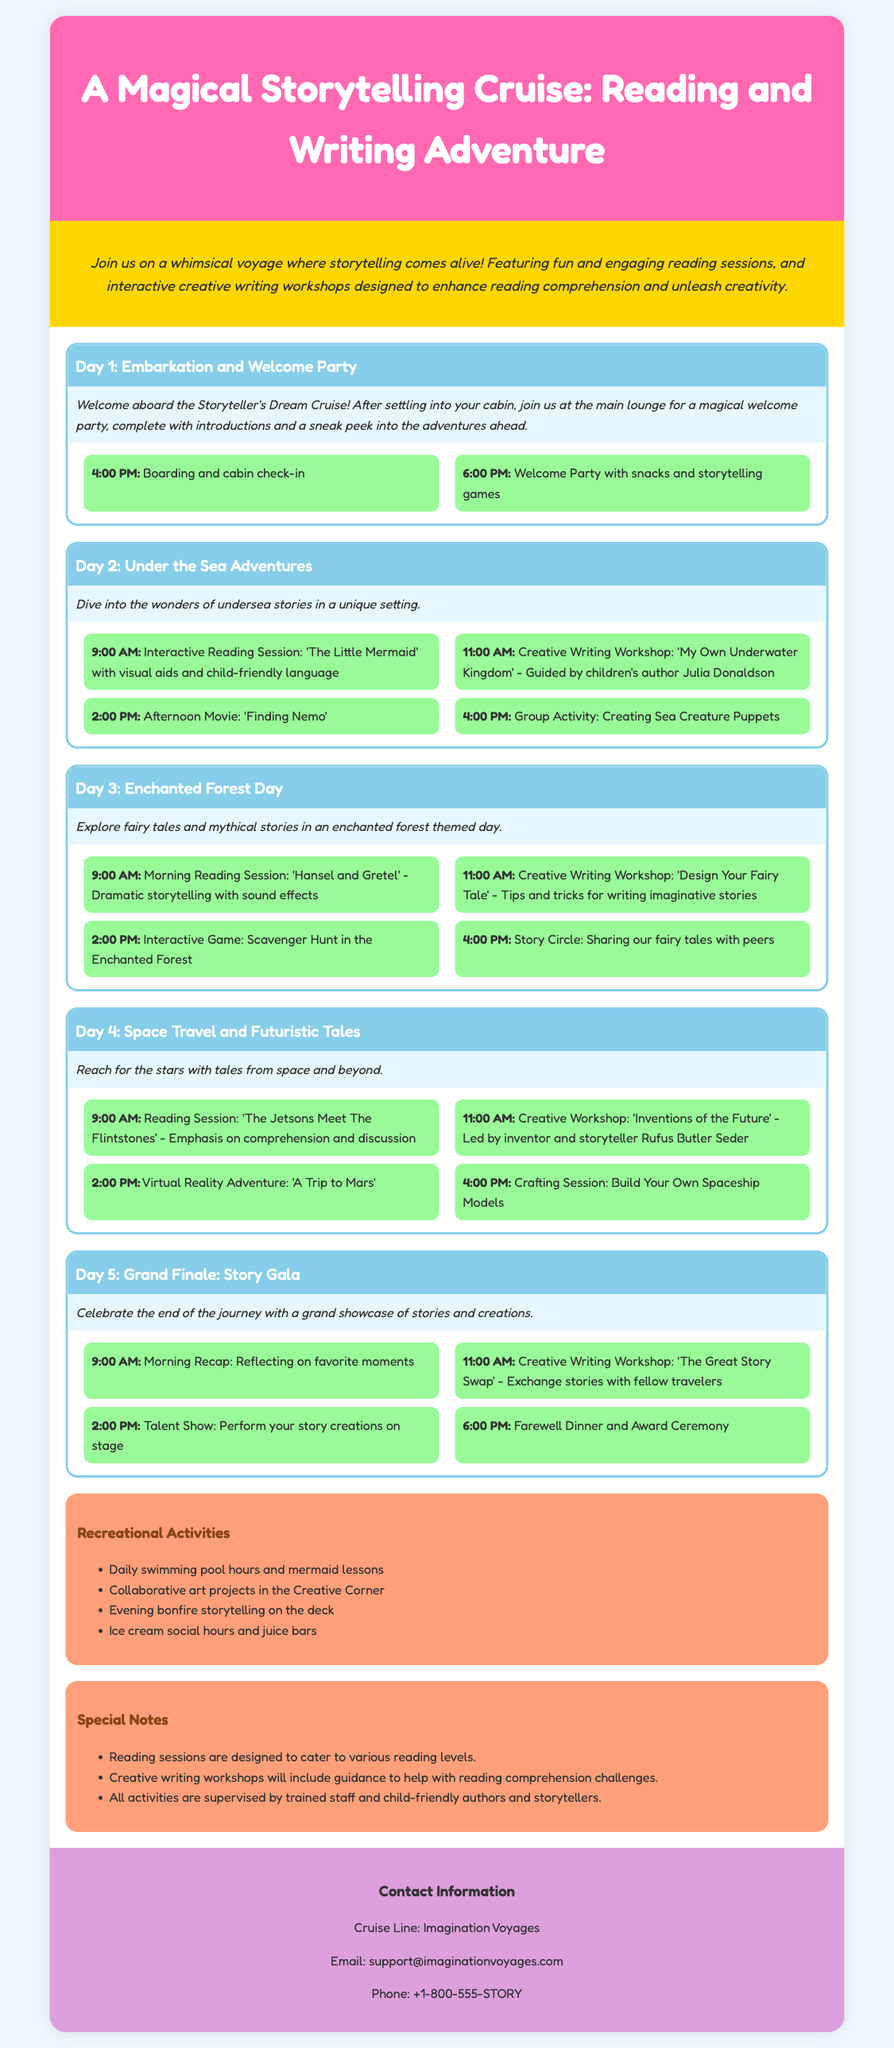What is the name of the cruise line? The document mentions the cruise line as "Imagination Voyages."
Answer: Imagination Voyages How many days is the storytelling cruise? The itinerary outlines activities for five distinct days of the cruise.
Answer: 5 days What time does the welcome party start on Day 1? The schedule specifies that the welcome party begins at 6:00 PM on Day 1.
Answer: 6:00 PM Who leads the creative writing workshop on Day 2? The document states that children's author Julia Donaldson guides the creative writing workshop on Day 2.
Answer: Julia Donaldson What activity occurs at 2:00 PM on Day 4? At 2:00 PM on Day 4, there is a virtual reality adventure titled 'A Trip to Mars.'
Answer: Virtual Reality Adventure: 'A Trip to Mars' What special notes are included regarding the reading sessions? The notes highlight that reading sessions are designed to cater to various reading levels.
Answer: Various reading levels Which day features a talent show? The grand finale on Day 5 includes a talent show where participants perform their story creations.
Answer: Day 5 What is the main theme of Day 3? Day 3 is centered around the theme of enchanted forests and related stories.
Answer: Enchanted Forest Day What type of activity is scheduled at 4:00 PM on Day 3? The itinerary schedules a story circle for sharing fairy tales at 4:00 PM on Day 3.
Answer: Story Circle 